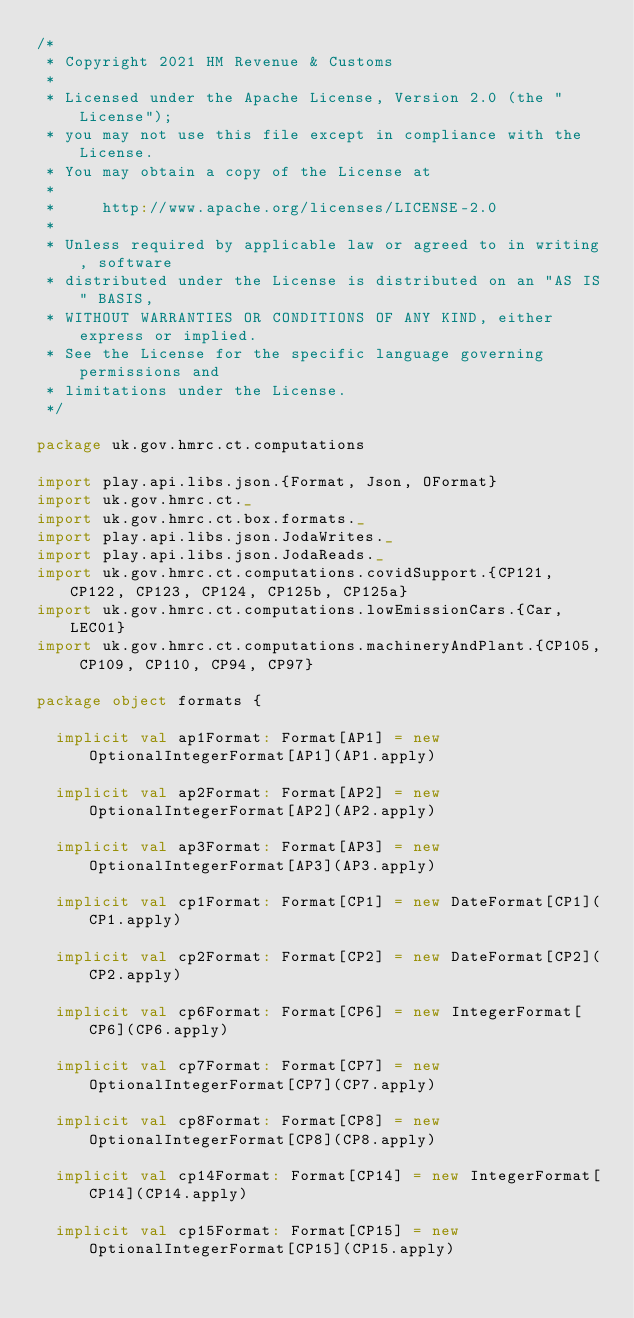<code> <loc_0><loc_0><loc_500><loc_500><_Scala_>/*
 * Copyright 2021 HM Revenue & Customs
 *
 * Licensed under the Apache License, Version 2.0 (the "License");
 * you may not use this file except in compliance with the License.
 * You may obtain a copy of the License at
 *
 *     http://www.apache.org/licenses/LICENSE-2.0
 *
 * Unless required by applicable law or agreed to in writing, software
 * distributed under the License is distributed on an "AS IS" BASIS,
 * WITHOUT WARRANTIES OR CONDITIONS OF ANY KIND, either express or implied.
 * See the License for the specific language governing permissions and
 * limitations under the License.
 */

package uk.gov.hmrc.ct.computations

import play.api.libs.json.{Format, Json, OFormat}
import uk.gov.hmrc.ct._
import uk.gov.hmrc.ct.box.formats._
import play.api.libs.json.JodaWrites._
import play.api.libs.json.JodaReads._
import uk.gov.hmrc.ct.computations.covidSupport.{CP121, CP122, CP123, CP124, CP125b, CP125a}
import uk.gov.hmrc.ct.computations.lowEmissionCars.{Car, LEC01}
import uk.gov.hmrc.ct.computations.machineryAndPlant.{CP105, CP109, CP110, CP94, CP97}

package object formats {

  implicit val ap1Format: Format[AP1] = new OptionalIntegerFormat[AP1](AP1.apply)

  implicit val ap2Format: Format[AP2] = new OptionalIntegerFormat[AP2](AP2.apply)

  implicit val ap3Format: Format[AP3] = new OptionalIntegerFormat[AP3](AP3.apply)

  implicit val cp1Format: Format[CP1] = new DateFormat[CP1](CP1.apply)

  implicit val cp2Format: Format[CP2] = new DateFormat[CP2](CP2.apply)

  implicit val cp6Format: Format[CP6] = new IntegerFormat[CP6](CP6.apply)

  implicit val cp7Format: Format[CP7] = new OptionalIntegerFormat[CP7](CP7.apply)

  implicit val cp8Format: Format[CP8] = new OptionalIntegerFormat[CP8](CP8.apply)

  implicit val cp14Format: Format[CP14] = new IntegerFormat[CP14](CP14.apply)

  implicit val cp15Format: Format[CP15] = new OptionalIntegerFormat[CP15](CP15.apply)
</code> 